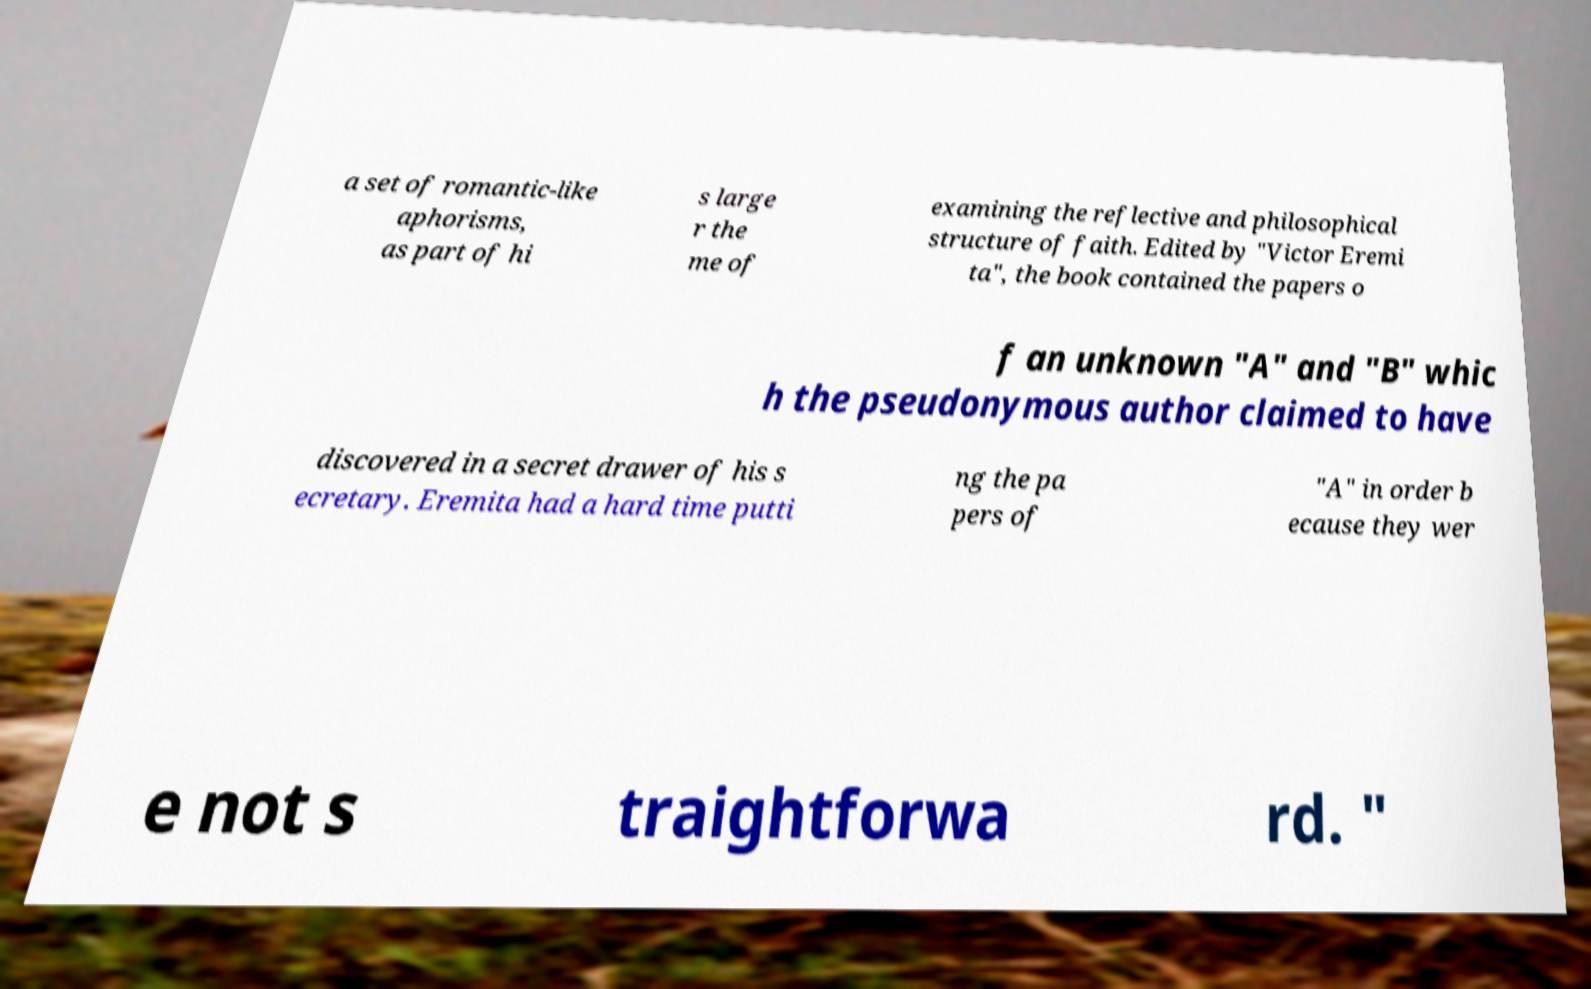Please identify and transcribe the text found in this image. a set of romantic-like aphorisms, as part of hi s large r the me of examining the reflective and philosophical structure of faith. Edited by "Victor Eremi ta", the book contained the papers o f an unknown "A" and "B" whic h the pseudonymous author claimed to have discovered in a secret drawer of his s ecretary. Eremita had a hard time putti ng the pa pers of "A" in order b ecause they wer e not s traightforwa rd. " 